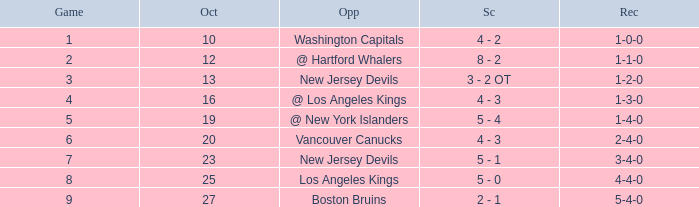Which game has the highest score in October with 9? 27.0. 